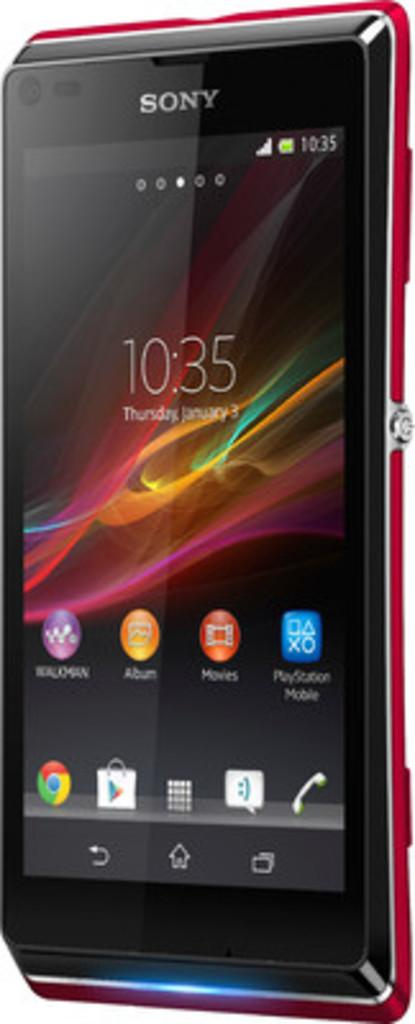Provide a one-sentence caption for the provided image. a Sony cell phone with a screen showing the time as 10:35. 